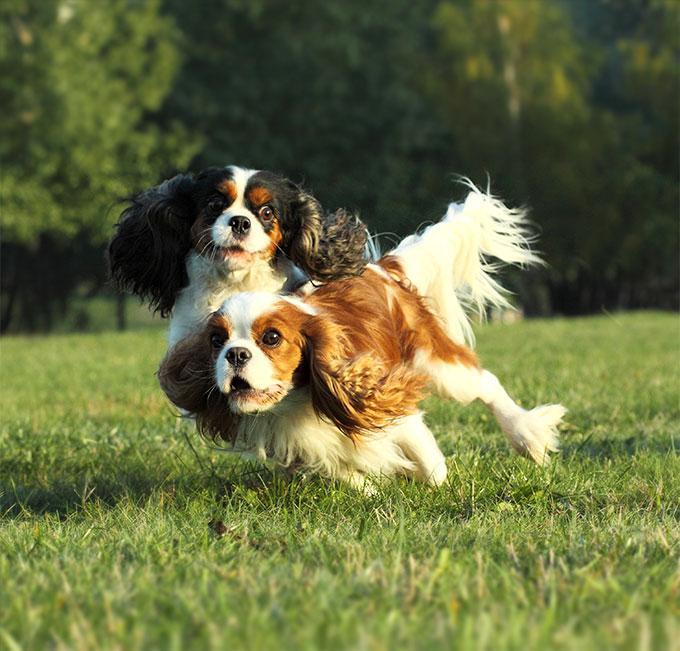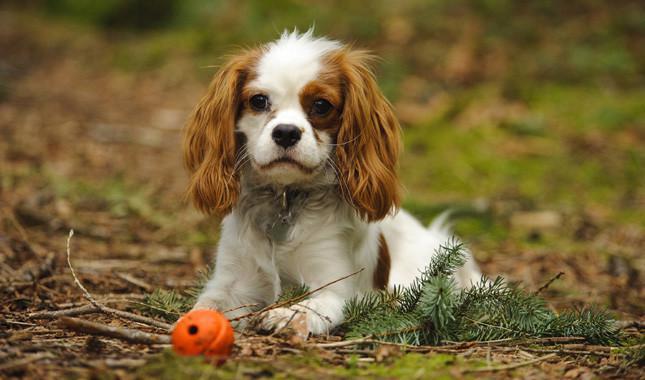The first image is the image on the left, the second image is the image on the right. Examine the images to the left and right. Is the description "2 dogs exactly can be seen and they are both facing the same way." accurate? Answer yes or no. No. The first image is the image on the left, the second image is the image on the right. Examine the images to the left and right. Is the description "Each image contains exactly one spaniel, and only the dog on the right is posed on real grass." accurate? Answer yes or no. No. 